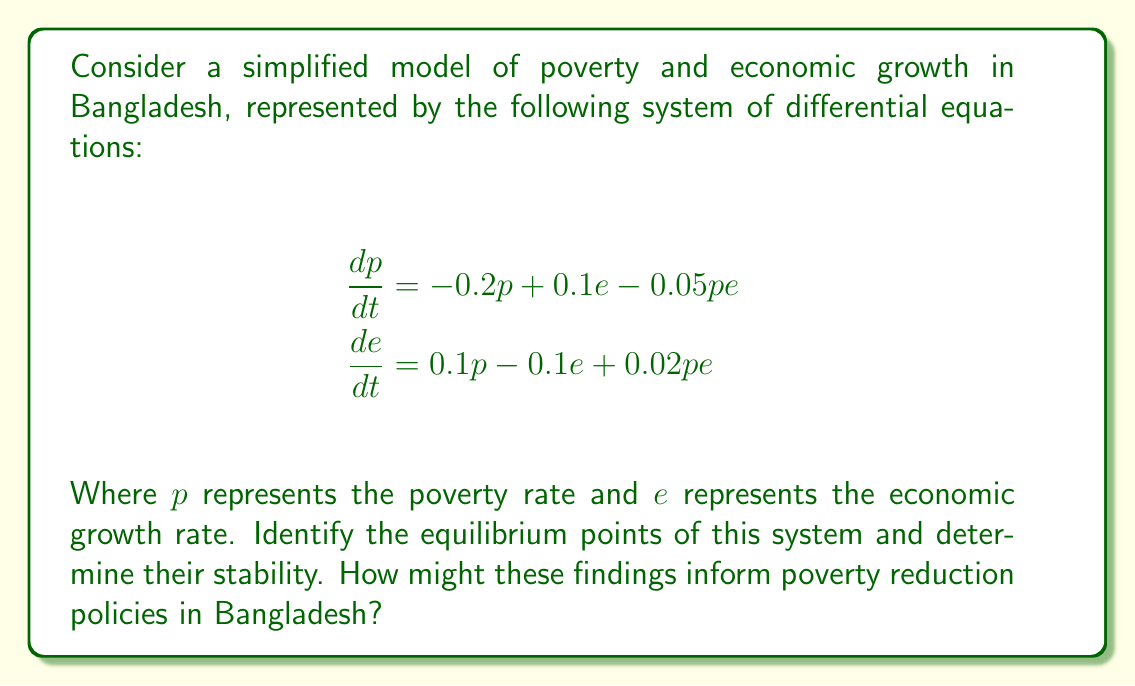Provide a solution to this math problem. 1. To find the equilibrium points, set both equations to zero:

   $$\begin{align}
   -0.2p + 0.1e - 0.05pe &= 0 \\
   0.1p - 0.1e + 0.02pe &= 0
   \end{align}$$

2. Solving these equations:
   
   a) Trivial equilibrium: $(p, e) = (0, 0)$
   
   b) Non-trivial equilibrium:
      Solving the system of equations yields $(p, e) = (2, 2)$

3. To determine stability, we need to find the Jacobian matrix:

   $$J = \begin{bmatrix}
   -0.2 - 0.05e & 0.1 - 0.05p \\
   0.1 + 0.02e & -0.1 + 0.02p
   \end{bmatrix}$$

4. Evaluate the Jacobian at each equilibrium point:

   a) At $(0, 0)$:
      $$J_{(0,0)} = \begin{bmatrix}
      -0.2 & 0.1 \\
      0.1 & -0.1
      \end{bmatrix}$$
      
      Eigenvalues: $\lambda_1 \approx -0.25$, $\lambda_2 \approx -0.05$
      Both eigenvalues are negative, so $(0, 0)$ is a stable node.

   b) At $(2, 2)$:
      $$J_{(2,2)} = \begin{bmatrix}
      -0.3 & 0 \\
      0.14 & -0.06
      \end{bmatrix}$$
      
      Eigenvalues: $\lambda_1 = -0.3$, $\lambda_2 = -0.06$
      Both eigenvalues are negative, so $(2, 2)$ is also a stable node.

5. Interpretation for policy:
   - The existence of two stable equilibria suggests a poverty trap scenario.
   - The $(0, 0)$ equilibrium represents a state of no poverty and no economic growth.
   - The $(2, 2)$ equilibrium represents a state with both poverty and economic growth present.
   - Policies should aim to move the system towards the $(0, 0)$ equilibrium by simultaneously reducing poverty and promoting sustainable economic growth.
   - Interventions may need to be substantial to overcome the stability of the $(2, 2)$ equilibrium.
Answer: Two stable equilibria: $(0, 0)$ and $(2, 2)$, indicating a poverty trap scenario. 